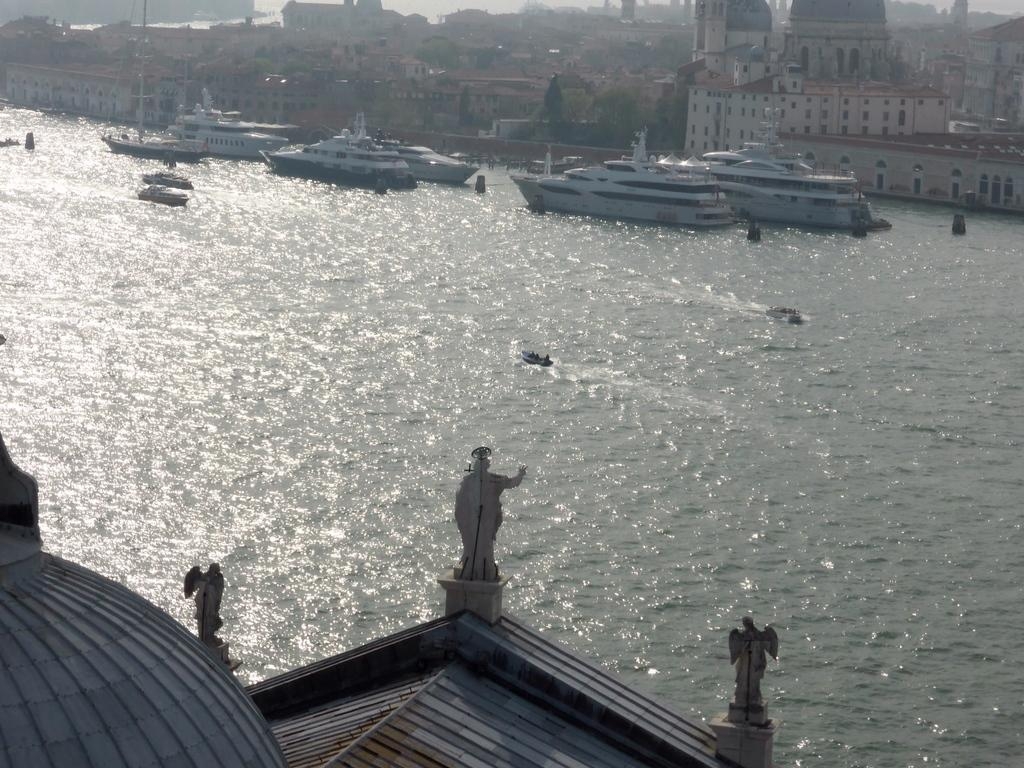What can be seen at the front of the image? There are statues in the front of the image. What is located in the middle of the image? There is water, ships, and boards in the middle of the image. What is visible in the background of the image? There are buildings and trees in the background of the image. Can you tell me how many teeth the ship has in the image? There are no teeth present on the ship in the image; it is a vessel used for transportation on water. Is there a partner visible in the image? There is no partner present in the image; it features statues, water, ships, boards, buildings, and trees. 